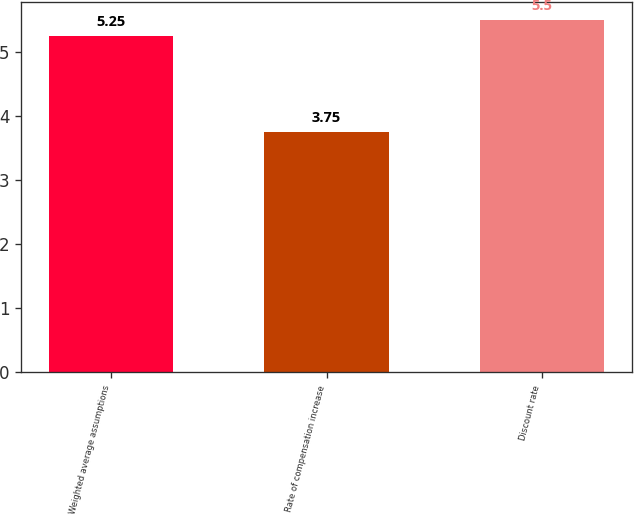Convert chart to OTSL. <chart><loc_0><loc_0><loc_500><loc_500><bar_chart><fcel>Weighted average assumptions<fcel>Rate of compensation increase<fcel>Discount rate<nl><fcel>5.25<fcel>3.75<fcel>5.5<nl></chart> 